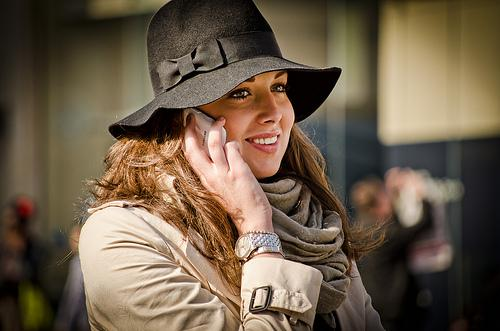Question: what gender is this person?
Choices:
A. Male.
B. Transgender Male.
C. Female.
D. Transgender Female.
Answer with the letter. Answer: C Question: what color is the woman's hat?
Choices:
A. Brown.
B. Grey.
C. Black.
D. Red.
Answer with the letter. Answer: C Question: what does the woman have in her right hand?
Choices:
A. A knife.
B. Cell phone.
C. A book.
D. A watch.
Answer with the letter. Answer: B Question: how many fingers are fully visible?
Choices:
A. Four.
B. Two.
C. Three.
D. One.
Answer with the letter. Answer: C 